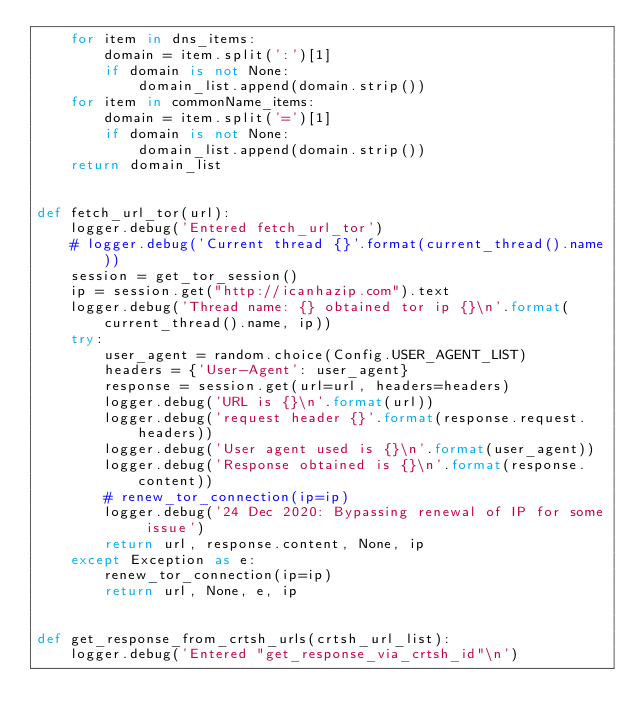Convert code to text. <code><loc_0><loc_0><loc_500><loc_500><_Python_>    for item in dns_items:
        domain = item.split(':')[1]
        if domain is not None:
            domain_list.append(domain.strip())
    for item in commonName_items:
        domain = item.split('=')[1]
        if domain is not None:
            domain_list.append(domain.strip())
    return domain_list


def fetch_url_tor(url):
    logger.debug('Entered fetch_url_tor')
    # logger.debug('Current thread {}'.format(current_thread().name))
    session = get_tor_session()
    ip = session.get("http://icanhazip.com").text
    logger.debug('Thread name: {} obtained tor ip {}\n'.format(current_thread().name, ip))
    try:
        user_agent = random.choice(Config.USER_AGENT_LIST)
        headers = {'User-Agent': user_agent}
        response = session.get(url=url, headers=headers)
        logger.debug('URL is {}\n'.format(url))
        logger.debug('request header {}'.format(response.request.headers))
        logger.debug('User agent used is {}\n'.format(user_agent))
        logger.debug('Response obtained is {}\n'.format(response.content))
        # renew_tor_connection(ip=ip)
        logger.debug('24 Dec 2020: Bypassing renewal of IP for some issue')
        return url, response.content, None, ip
    except Exception as e:
        renew_tor_connection(ip=ip)
        return url, None, e, ip


def get_response_from_crtsh_urls(crtsh_url_list):
    logger.debug('Entered "get_response_via_crtsh_id"\n')</code> 